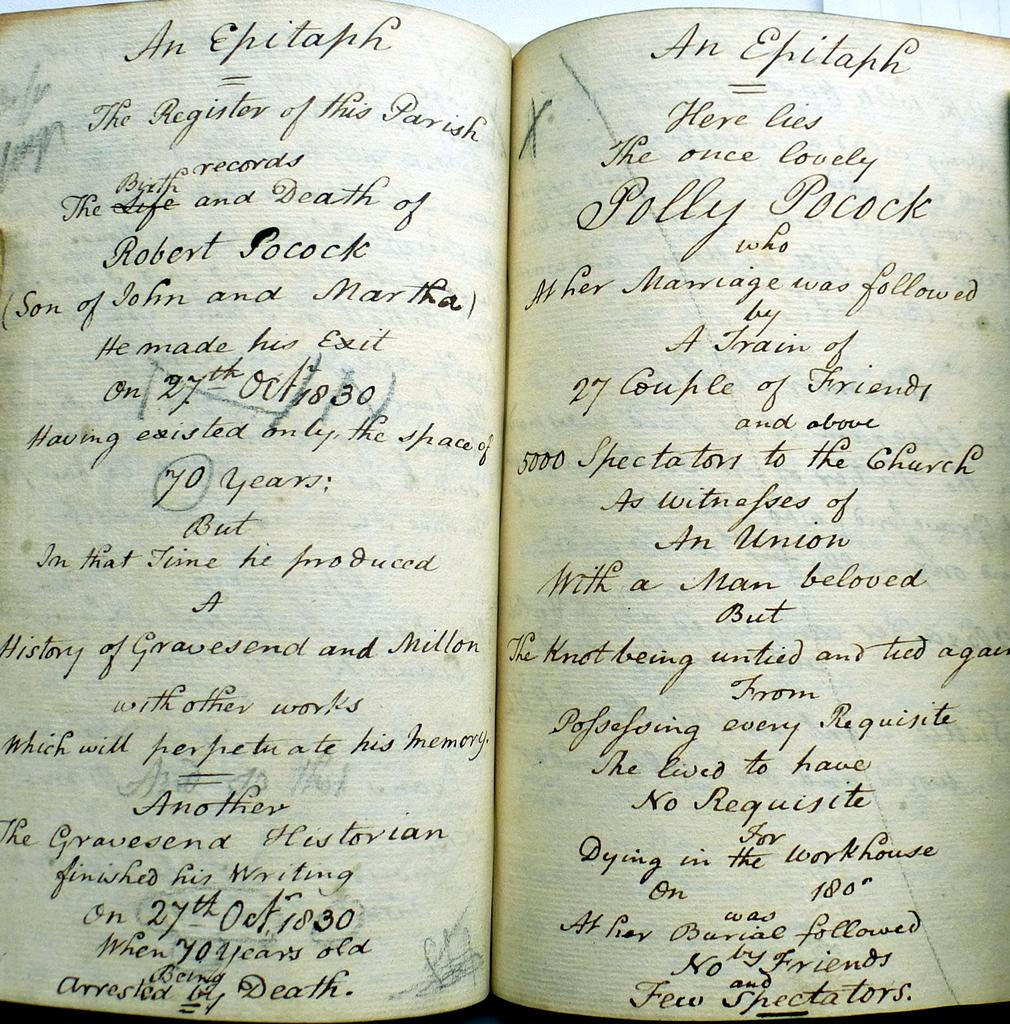<image>
Render a clear and concise summary of the photo. A book with handwritten cursive stating it is an epitaph. 